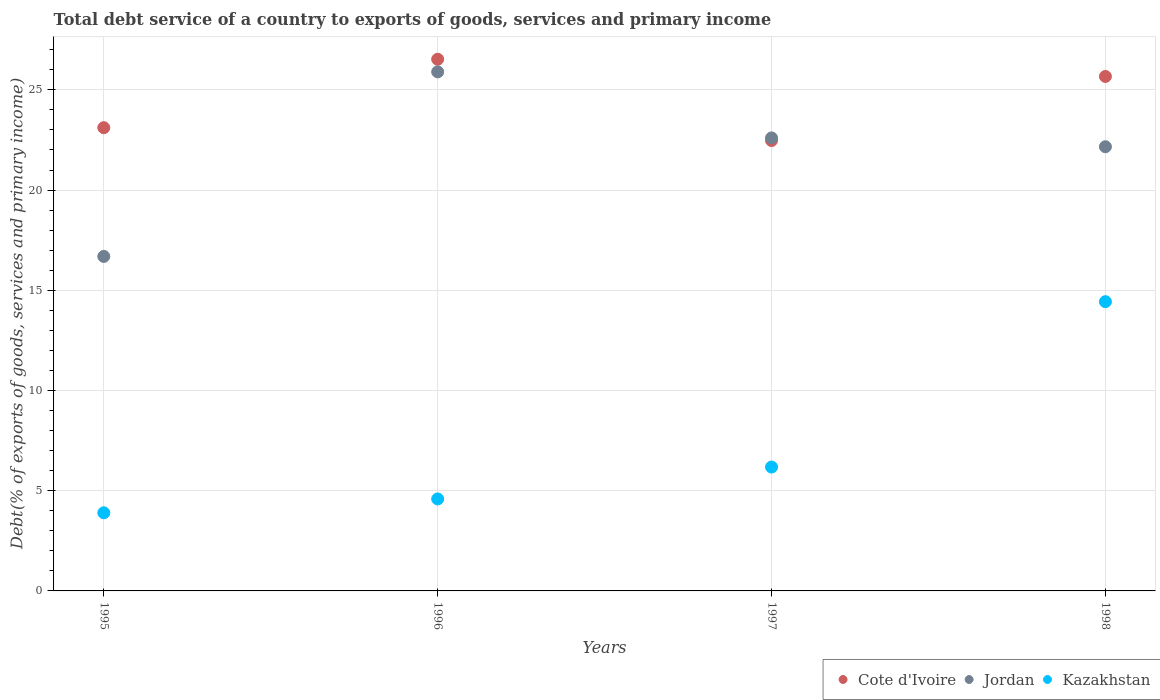What is the total debt service in Jordan in 1997?
Provide a short and direct response. 22.6. Across all years, what is the maximum total debt service in Kazakhstan?
Provide a short and direct response. 14.43. Across all years, what is the minimum total debt service in Jordan?
Your response must be concise. 16.69. In which year was the total debt service in Jordan maximum?
Your answer should be compact. 1996. What is the total total debt service in Kazakhstan in the graph?
Your answer should be very brief. 29.1. What is the difference between the total debt service in Kazakhstan in 1997 and that in 1998?
Offer a terse response. -8.25. What is the difference between the total debt service in Jordan in 1995 and the total debt service in Cote d'Ivoire in 1997?
Ensure brevity in your answer.  -5.78. What is the average total debt service in Cote d'Ivoire per year?
Offer a terse response. 24.44. In the year 1997, what is the difference between the total debt service in Kazakhstan and total debt service in Jordan?
Offer a terse response. -16.42. What is the ratio of the total debt service in Kazakhstan in 1995 to that in 1996?
Provide a succinct answer. 0.85. Is the difference between the total debt service in Kazakhstan in 1997 and 1998 greater than the difference between the total debt service in Jordan in 1997 and 1998?
Offer a terse response. No. What is the difference between the highest and the second highest total debt service in Kazakhstan?
Offer a very short reply. 8.25. What is the difference between the highest and the lowest total debt service in Jordan?
Keep it short and to the point. 9.21. Is the sum of the total debt service in Jordan in 1995 and 1998 greater than the maximum total debt service in Kazakhstan across all years?
Give a very brief answer. Yes. Is it the case that in every year, the sum of the total debt service in Cote d'Ivoire and total debt service in Kazakhstan  is greater than the total debt service in Jordan?
Ensure brevity in your answer.  Yes. How many dotlines are there?
Provide a succinct answer. 3. How many years are there in the graph?
Provide a succinct answer. 4. Does the graph contain any zero values?
Keep it short and to the point. No. Where does the legend appear in the graph?
Make the answer very short. Bottom right. How many legend labels are there?
Make the answer very short. 3. What is the title of the graph?
Keep it short and to the point. Total debt service of a country to exports of goods, services and primary income. What is the label or title of the X-axis?
Your response must be concise. Years. What is the label or title of the Y-axis?
Your answer should be compact. Debt(% of exports of goods, services and primary income). What is the Debt(% of exports of goods, services and primary income) in Cote d'Ivoire in 1995?
Your response must be concise. 23.11. What is the Debt(% of exports of goods, services and primary income) in Jordan in 1995?
Give a very brief answer. 16.69. What is the Debt(% of exports of goods, services and primary income) in Kazakhstan in 1995?
Offer a terse response. 3.9. What is the Debt(% of exports of goods, services and primary income) in Cote d'Ivoire in 1996?
Your answer should be compact. 26.53. What is the Debt(% of exports of goods, services and primary income) in Jordan in 1996?
Provide a succinct answer. 25.9. What is the Debt(% of exports of goods, services and primary income) of Kazakhstan in 1996?
Your answer should be compact. 4.59. What is the Debt(% of exports of goods, services and primary income) in Cote d'Ivoire in 1997?
Give a very brief answer. 22.47. What is the Debt(% of exports of goods, services and primary income) of Jordan in 1997?
Provide a short and direct response. 22.6. What is the Debt(% of exports of goods, services and primary income) of Kazakhstan in 1997?
Give a very brief answer. 6.18. What is the Debt(% of exports of goods, services and primary income) of Cote d'Ivoire in 1998?
Your answer should be very brief. 25.67. What is the Debt(% of exports of goods, services and primary income) in Jordan in 1998?
Ensure brevity in your answer.  22.16. What is the Debt(% of exports of goods, services and primary income) of Kazakhstan in 1998?
Your response must be concise. 14.43. Across all years, what is the maximum Debt(% of exports of goods, services and primary income) in Cote d'Ivoire?
Your response must be concise. 26.53. Across all years, what is the maximum Debt(% of exports of goods, services and primary income) in Jordan?
Your answer should be very brief. 25.9. Across all years, what is the maximum Debt(% of exports of goods, services and primary income) in Kazakhstan?
Your answer should be compact. 14.43. Across all years, what is the minimum Debt(% of exports of goods, services and primary income) in Cote d'Ivoire?
Provide a succinct answer. 22.47. Across all years, what is the minimum Debt(% of exports of goods, services and primary income) of Jordan?
Offer a terse response. 16.69. Across all years, what is the minimum Debt(% of exports of goods, services and primary income) of Kazakhstan?
Offer a terse response. 3.9. What is the total Debt(% of exports of goods, services and primary income) in Cote d'Ivoire in the graph?
Give a very brief answer. 97.78. What is the total Debt(% of exports of goods, services and primary income) of Jordan in the graph?
Provide a short and direct response. 87.35. What is the total Debt(% of exports of goods, services and primary income) in Kazakhstan in the graph?
Make the answer very short. 29.1. What is the difference between the Debt(% of exports of goods, services and primary income) of Cote d'Ivoire in 1995 and that in 1996?
Make the answer very short. -3.41. What is the difference between the Debt(% of exports of goods, services and primary income) in Jordan in 1995 and that in 1996?
Offer a very short reply. -9.21. What is the difference between the Debt(% of exports of goods, services and primary income) of Kazakhstan in 1995 and that in 1996?
Ensure brevity in your answer.  -0.69. What is the difference between the Debt(% of exports of goods, services and primary income) of Cote d'Ivoire in 1995 and that in 1997?
Keep it short and to the point. 0.64. What is the difference between the Debt(% of exports of goods, services and primary income) in Jordan in 1995 and that in 1997?
Your answer should be very brief. -5.91. What is the difference between the Debt(% of exports of goods, services and primary income) of Kazakhstan in 1995 and that in 1997?
Ensure brevity in your answer.  -2.28. What is the difference between the Debt(% of exports of goods, services and primary income) in Cote d'Ivoire in 1995 and that in 1998?
Make the answer very short. -2.56. What is the difference between the Debt(% of exports of goods, services and primary income) of Jordan in 1995 and that in 1998?
Provide a short and direct response. -5.47. What is the difference between the Debt(% of exports of goods, services and primary income) of Kazakhstan in 1995 and that in 1998?
Offer a terse response. -10.53. What is the difference between the Debt(% of exports of goods, services and primary income) of Cote d'Ivoire in 1996 and that in 1997?
Ensure brevity in your answer.  4.06. What is the difference between the Debt(% of exports of goods, services and primary income) of Jordan in 1996 and that in 1997?
Your answer should be compact. 3.29. What is the difference between the Debt(% of exports of goods, services and primary income) in Kazakhstan in 1996 and that in 1997?
Ensure brevity in your answer.  -1.59. What is the difference between the Debt(% of exports of goods, services and primary income) in Cote d'Ivoire in 1996 and that in 1998?
Make the answer very short. 0.86. What is the difference between the Debt(% of exports of goods, services and primary income) of Jordan in 1996 and that in 1998?
Make the answer very short. 3.74. What is the difference between the Debt(% of exports of goods, services and primary income) of Kazakhstan in 1996 and that in 1998?
Ensure brevity in your answer.  -9.84. What is the difference between the Debt(% of exports of goods, services and primary income) of Cote d'Ivoire in 1997 and that in 1998?
Offer a very short reply. -3.2. What is the difference between the Debt(% of exports of goods, services and primary income) of Jordan in 1997 and that in 1998?
Provide a succinct answer. 0.44. What is the difference between the Debt(% of exports of goods, services and primary income) in Kazakhstan in 1997 and that in 1998?
Ensure brevity in your answer.  -8.25. What is the difference between the Debt(% of exports of goods, services and primary income) in Cote d'Ivoire in 1995 and the Debt(% of exports of goods, services and primary income) in Jordan in 1996?
Provide a succinct answer. -2.79. What is the difference between the Debt(% of exports of goods, services and primary income) of Cote d'Ivoire in 1995 and the Debt(% of exports of goods, services and primary income) of Kazakhstan in 1996?
Keep it short and to the point. 18.52. What is the difference between the Debt(% of exports of goods, services and primary income) of Jordan in 1995 and the Debt(% of exports of goods, services and primary income) of Kazakhstan in 1996?
Offer a terse response. 12.1. What is the difference between the Debt(% of exports of goods, services and primary income) of Cote d'Ivoire in 1995 and the Debt(% of exports of goods, services and primary income) of Jordan in 1997?
Keep it short and to the point. 0.51. What is the difference between the Debt(% of exports of goods, services and primary income) in Cote d'Ivoire in 1995 and the Debt(% of exports of goods, services and primary income) in Kazakhstan in 1997?
Your answer should be very brief. 16.93. What is the difference between the Debt(% of exports of goods, services and primary income) of Jordan in 1995 and the Debt(% of exports of goods, services and primary income) of Kazakhstan in 1997?
Make the answer very short. 10.51. What is the difference between the Debt(% of exports of goods, services and primary income) in Cote d'Ivoire in 1995 and the Debt(% of exports of goods, services and primary income) in Jordan in 1998?
Keep it short and to the point. 0.95. What is the difference between the Debt(% of exports of goods, services and primary income) in Cote d'Ivoire in 1995 and the Debt(% of exports of goods, services and primary income) in Kazakhstan in 1998?
Your answer should be very brief. 8.68. What is the difference between the Debt(% of exports of goods, services and primary income) in Jordan in 1995 and the Debt(% of exports of goods, services and primary income) in Kazakhstan in 1998?
Give a very brief answer. 2.26. What is the difference between the Debt(% of exports of goods, services and primary income) in Cote d'Ivoire in 1996 and the Debt(% of exports of goods, services and primary income) in Jordan in 1997?
Provide a succinct answer. 3.92. What is the difference between the Debt(% of exports of goods, services and primary income) of Cote d'Ivoire in 1996 and the Debt(% of exports of goods, services and primary income) of Kazakhstan in 1997?
Provide a short and direct response. 20.35. What is the difference between the Debt(% of exports of goods, services and primary income) of Jordan in 1996 and the Debt(% of exports of goods, services and primary income) of Kazakhstan in 1997?
Keep it short and to the point. 19.72. What is the difference between the Debt(% of exports of goods, services and primary income) in Cote d'Ivoire in 1996 and the Debt(% of exports of goods, services and primary income) in Jordan in 1998?
Offer a terse response. 4.36. What is the difference between the Debt(% of exports of goods, services and primary income) of Cote d'Ivoire in 1996 and the Debt(% of exports of goods, services and primary income) of Kazakhstan in 1998?
Provide a short and direct response. 12.09. What is the difference between the Debt(% of exports of goods, services and primary income) of Jordan in 1996 and the Debt(% of exports of goods, services and primary income) of Kazakhstan in 1998?
Ensure brevity in your answer.  11.47. What is the difference between the Debt(% of exports of goods, services and primary income) in Cote d'Ivoire in 1997 and the Debt(% of exports of goods, services and primary income) in Jordan in 1998?
Keep it short and to the point. 0.31. What is the difference between the Debt(% of exports of goods, services and primary income) of Cote d'Ivoire in 1997 and the Debt(% of exports of goods, services and primary income) of Kazakhstan in 1998?
Offer a very short reply. 8.04. What is the difference between the Debt(% of exports of goods, services and primary income) in Jordan in 1997 and the Debt(% of exports of goods, services and primary income) in Kazakhstan in 1998?
Your answer should be very brief. 8.17. What is the average Debt(% of exports of goods, services and primary income) in Cote d'Ivoire per year?
Keep it short and to the point. 24.44. What is the average Debt(% of exports of goods, services and primary income) in Jordan per year?
Offer a terse response. 21.84. What is the average Debt(% of exports of goods, services and primary income) of Kazakhstan per year?
Provide a short and direct response. 7.27. In the year 1995, what is the difference between the Debt(% of exports of goods, services and primary income) of Cote d'Ivoire and Debt(% of exports of goods, services and primary income) of Jordan?
Your response must be concise. 6.42. In the year 1995, what is the difference between the Debt(% of exports of goods, services and primary income) in Cote d'Ivoire and Debt(% of exports of goods, services and primary income) in Kazakhstan?
Offer a very short reply. 19.21. In the year 1995, what is the difference between the Debt(% of exports of goods, services and primary income) in Jordan and Debt(% of exports of goods, services and primary income) in Kazakhstan?
Offer a terse response. 12.79. In the year 1996, what is the difference between the Debt(% of exports of goods, services and primary income) in Cote d'Ivoire and Debt(% of exports of goods, services and primary income) in Jordan?
Your response must be concise. 0.63. In the year 1996, what is the difference between the Debt(% of exports of goods, services and primary income) of Cote d'Ivoire and Debt(% of exports of goods, services and primary income) of Kazakhstan?
Give a very brief answer. 21.94. In the year 1996, what is the difference between the Debt(% of exports of goods, services and primary income) of Jordan and Debt(% of exports of goods, services and primary income) of Kazakhstan?
Give a very brief answer. 21.31. In the year 1997, what is the difference between the Debt(% of exports of goods, services and primary income) in Cote d'Ivoire and Debt(% of exports of goods, services and primary income) in Jordan?
Offer a terse response. -0.13. In the year 1997, what is the difference between the Debt(% of exports of goods, services and primary income) in Cote d'Ivoire and Debt(% of exports of goods, services and primary income) in Kazakhstan?
Your response must be concise. 16.29. In the year 1997, what is the difference between the Debt(% of exports of goods, services and primary income) in Jordan and Debt(% of exports of goods, services and primary income) in Kazakhstan?
Offer a very short reply. 16.42. In the year 1998, what is the difference between the Debt(% of exports of goods, services and primary income) of Cote d'Ivoire and Debt(% of exports of goods, services and primary income) of Jordan?
Ensure brevity in your answer.  3.51. In the year 1998, what is the difference between the Debt(% of exports of goods, services and primary income) of Cote d'Ivoire and Debt(% of exports of goods, services and primary income) of Kazakhstan?
Provide a succinct answer. 11.24. In the year 1998, what is the difference between the Debt(% of exports of goods, services and primary income) in Jordan and Debt(% of exports of goods, services and primary income) in Kazakhstan?
Give a very brief answer. 7.73. What is the ratio of the Debt(% of exports of goods, services and primary income) of Cote d'Ivoire in 1995 to that in 1996?
Your answer should be very brief. 0.87. What is the ratio of the Debt(% of exports of goods, services and primary income) of Jordan in 1995 to that in 1996?
Ensure brevity in your answer.  0.64. What is the ratio of the Debt(% of exports of goods, services and primary income) of Kazakhstan in 1995 to that in 1996?
Keep it short and to the point. 0.85. What is the ratio of the Debt(% of exports of goods, services and primary income) in Cote d'Ivoire in 1995 to that in 1997?
Provide a short and direct response. 1.03. What is the ratio of the Debt(% of exports of goods, services and primary income) in Jordan in 1995 to that in 1997?
Give a very brief answer. 0.74. What is the ratio of the Debt(% of exports of goods, services and primary income) in Kazakhstan in 1995 to that in 1997?
Your answer should be compact. 0.63. What is the ratio of the Debt(% of exports of goods, services and primary income) in Cote d'Ivoire in 1995 to that in 1998?
Offer a terse response. 0.9. What is the ratio of the Debt(% of exports of goods, services and primary income) of Jordan in 1995 to that in 1998?
Keep it short and to the point. 0.75. What is the ratio of the Debt(% of exports of goods, services and primary income) of Kazakhstan in 1995 to that in 1998?
Your answer should be very brief. 0.27. What is the ratio of the Debt(% of exports of goods, services and primary income) in Cote d'Ivoire in 1996 to that in 1997?
Make the answer very short. 1.18. What is the ratio of the Debt(% of exports of goods, services and primary income) in Jordan in 1996 to that in 1997?
Your answer should be compact. 1.15. What is the ratio of the Debt(% of exports of goods, services and primary income) in Kazakhstan in 1996 to that in 1997?
Ensure brevity in your answer.  0.74. What is the ratio of the Debt(% of exports of goods, services and primary income) in Cote d'Ivoire in 1996 to that in 1998?
Offer a very short reply. 1.03. What is the ratio of the Debt(% of exports of goods, services and primary income) of Jordan in 1996 to that in 1998?
Keep it short and to the point. 1.17. What is the ratio of the Debt(% of exports of goods, services and primary income) of Kazakhstan in 1996 to that in 1998?
Offer a terse response. 0.32. What is the ratio of the Debt(% of exports of goods, services and primary income) of Cote d'Ivoire in 1997 to that in 1998?
Provide a short and direct response. 0.88. What is the ratio of the Debt(% of exports of goods, services and primary income) in Jordan in 1997 to that in 1998?
Provide a short and direct response. 1.02. What is the ratio of the Debt(% of exports of goods, services and primary income) of Kazakhstan in 1997 to that in 1998?
Your answer should be very brief. 0.43. What is the difference between the highest and the second highest Debt(% of exports of goods, services and primary income) of Cote d'Ivoire?
Offer a very short reply. 0.86. What is the difference between the highest and the second highest Debt(% of exports of goods, services and primary income) of Jordan?
Your answer should be very brief. 3.29. What is the difference between the highest and the second highest Debt(% of exports of goods, services and primary income) in Kazakhstan?
Provide a succinct answer. 8.25. What is the difference between the highest and the lowest Debt(% of exports of goods, services and primary income) of Cote d'Ivoire?
Keep it short and to the point. 4.06. What is the difference between the highest and the lowest Debt(% of exports of goods, services and primary income) of Jordan?
Your answer should be very brief. 9.21. What is the difference between the highest and the lowest Debt(% of exports of goods, services and primary income) of Kazakhstan?
Offer a terse response. 10.53. 